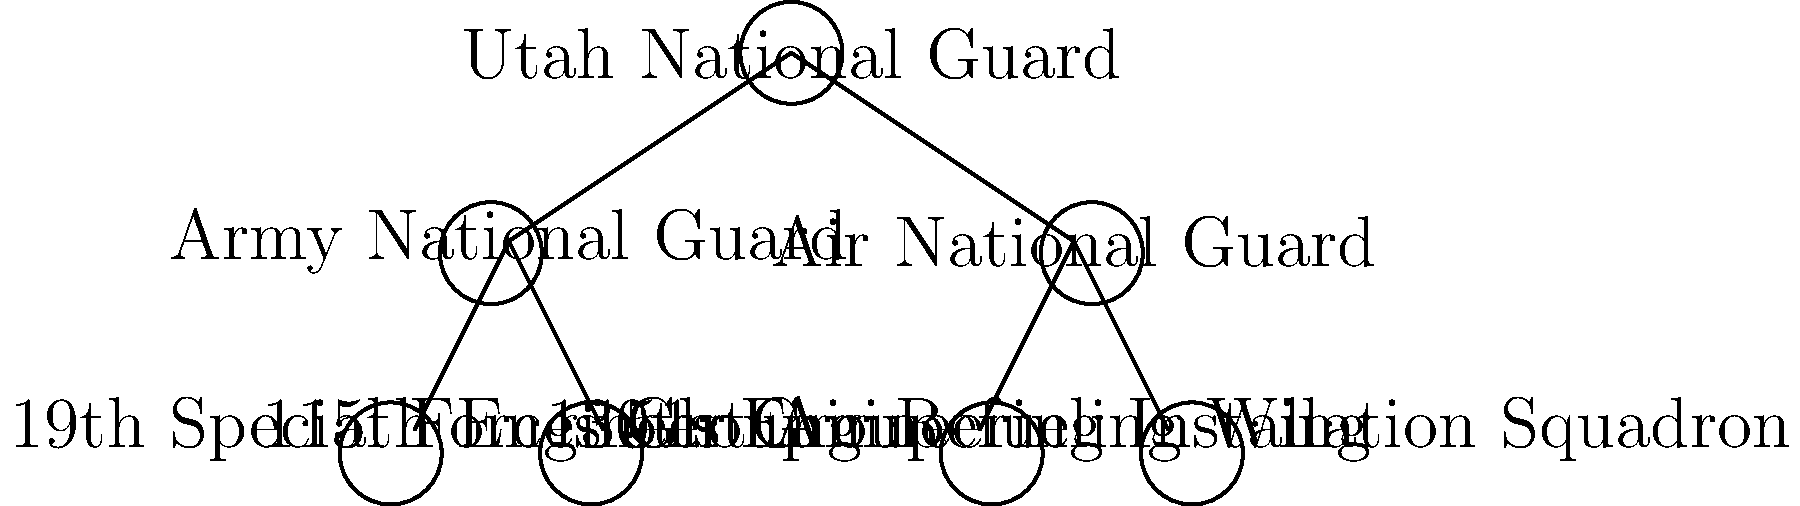In the hierarchical structure of Utah's National Guard units shown above, how many direct subordinate units does the Army National Guard have? To answer this question, we need to analyze the tree diagram representing the hierarchical structure of Utah's National Guard units:

1. The top-level node represents the Utah National Guard.
2. The Utah National Guard has two main branches: Army National Guard and Air National Guard.
3. We need to focus on the Army National Guard branch.
4. Looking at the diagram, we can see that the Army National Guard node has two lines connecting it to lower-level units.
5. These two units are:
   a. 19th Special Forces Group
   b. 115th Engineer Group
6. Therefore, the Army National Guard has two direct subordinate units in this hierarchical structure.

It's important to note that this diagram may not represent the entire structure of Utah's National Guard, but rather a simplified version for illustration purposes. In reality, there might be more units under each branch.
Answer: 2 